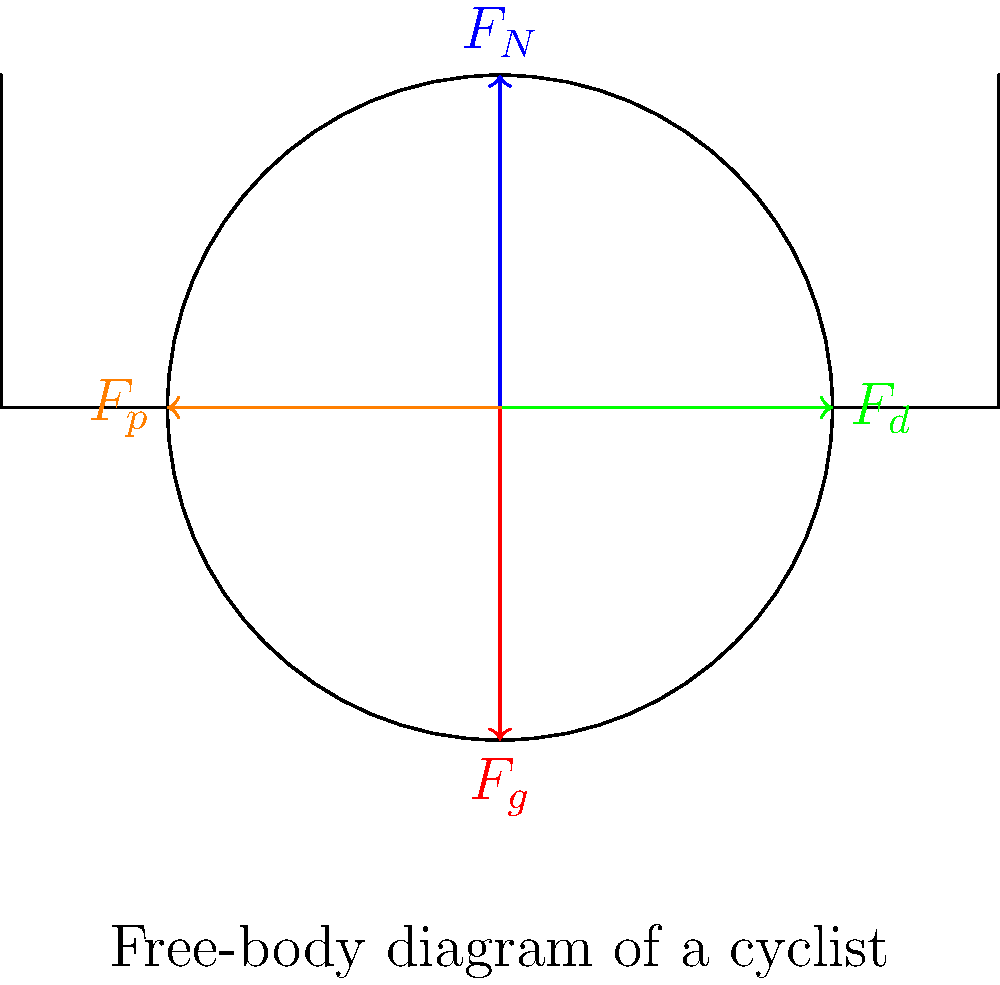As a sports journalist analyzing the physics of cycling, consider a professional cyclist during a flat stage of a race. Using the free-body diagram provided, which shows the forces acting on the cyclist, explain how these forces affect the cyclist's motion. Additionally, if the cyclist is moving at a constant velocity, what can be concluded about the relationship between these forces? To understand the forces acting on the cyclist and their effects, let's break down the free-body diagram:

1. Normal Force ($F_N$): This is the upward force exerted by the ground on the cyclist and bicycle. It counteracts the force of gravity.

2. Gravitational Force ($F_g$): This is the downward force due to the Earth's gravity acting on the cyclist and bicycle.

3. Drag Force ($F_d$): This is the air resistance acting against the cyclist's motion. It increases with the cyclist's speed.

4. Propulsive Force ($F_p$): This is the forward force generated by the cyclist pedaling, propelling the bicycle forward.

The effects of these forces on the cyclist's motion:
- $F_N$ and $F_g$ balance each other out on a flat surface, resulting in no vertical acceleration.
- $F_d$ opposes the cyclist's motion, slowing them down if not countered.
- $F_p$ propels the cyclist forward, overcoming drag and maintaining or increasing speed.

If the cyclist is moving at a constant velocity:
1. There is no acceleration in any direction.
2. The sum of all forces must equal zero (Newton's First Law).
3. In the horizontal direction: $F_p = F_d$ (propulsive force equals drag force).
4. In the vertical direction: $F_N = F_g$ (normal force equals gravitational force).

This balanced state is called dynamic equilibrium, where the cyclist maintains a constant speed by exactly counteracting the drag force with their pedaling effort.
Answer: At constant velocity, $F_p = F_d$ and $F_N = F_g$, resulting in dynamic equilibrium. 